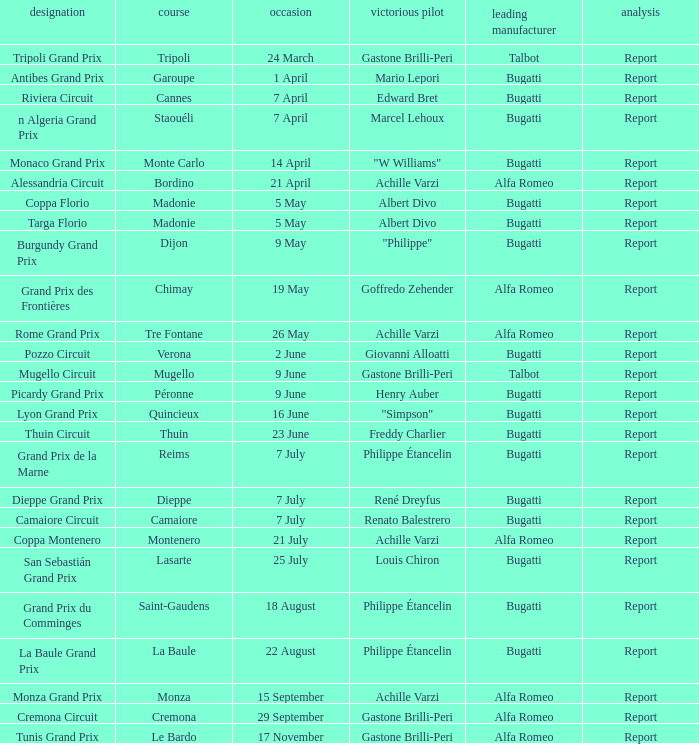What Date has a Name of thuin circuit? 23 June. Can you parse all the data within this table? {'header': ['designation', 'course', 'occasion', 'victorious pilot', 'leading manufacturer', 'analysis'], 'rows': [['Tripoli Grand Prix', 'Tripoli', '24 March', 'Gastone Brilli-Peri', 'Talbot', 'Report'], ['Antibes Grand Prix', 'Garoupe', '1 April', 'Mario Lepori', 'Bugatti', 'Report'], ['Riviera Circuit', 'Cannes', '7 April', 'Edward Bret', 'Bugatti', 'Report'], ['n Algeria Grand Prix', 'Staouéli', '7 April', 'Marcel Lehoux', 'Bugatti', 'Report'], ['Monaco Grand Prix', 'Monte Carlo', '14 April', '"W Williams"', 'Bugatti', 'Report'], ['Alessandria Circuit', 'Bordino', '21 April', 'Achille Varzi', 'Alfa Romeo', 'Report'], ['Coppa Florio', 'Madonie', '5 May', 'Albert Divo', 'Bugatti', 'Report'], ['Targa Florio', 'Madonie', '5 May', 'Albert Divo', 'Bugatti', 'Report'], ['Burgundy Grand Prix', 'Dijon', '9 May', '"Philippe"', 'Bugatti', 'Report'], ['Grand Prix des Frontières', 'Chimay', '19 May', 'Goffredo Zehender', 'Alfa Romeo', 'Report'], ['Rome Grand Prix', 'Tre Fontane', '26 May', 'Achille Varzi', 'Alfa Romeo', 'Report'], ['Pozzo Circuit', 'Verona', '2 June', 'Giovanni Alloatti', 'Bugatti', 'Report'], ['Mugello Circuit', 'Mugello', '9 June', 'Gastone Brilli-Peri', 'Talbot', 'Report'], ['Picardy Grand Prix', 'Péronne', '9 June', 'Henry Auber', 'Bugatti', 'Report'], ['Lyon Grand Prix', 'Quincieux', '16 June', '"Simpson"', 'Bugatti', 'Report'], ['Thuin Circuit', 'Thuin', '23 June', 'Freddy Charlier', 'Bugatti', 'Report'], ['Grand Prix de la Marne', 'Reims', '7 July', 'Philippe Étancelin', 'Bugatti', 'Report'], ['Dieppe Grand Prix', 'Dieppe', '7 July', 'René Dreyfus', 'Bugatti', 'Report'], ['Camaiore Circuit', 'Camaiore', '7 July', 'Renato Balestrero', 'Bugatti', 'Report'], ['Coppa Montenero', 'Montenero', '21 July', 'Achille Varzi', 'Alfa Romeo', 'Report'], ['San Sebastián Grand Prix', 'Lasarte', '25 July', 'Louis Chiron', 'Bugatti', 'Report'], ['Grand Prix du Comminges', 'Saint-Gaudens', '18 August', 'Philippe Étancelin', 'Bugatti', 'Report'], ['La Baule Grand Prix', 'La Baule', '22 August', 'Philippe Étancelin', 'Bugatti', 'Report'], ['Monza Grand Prix', 'Monza', '15 September', 'Achille Varzi', 'Alfa Romeo', 'Report'], ['Cremona Circuit', 'Cremona', '29 September', 'Gastone Brilli-Peri', 'Alfa Romeo', 'Report'], ['Tunis Grand Prix', 'Le Bardo', '17 November', 'Gastone Brilli-Peri', 'Alfa Romeo', 'Report']]} 